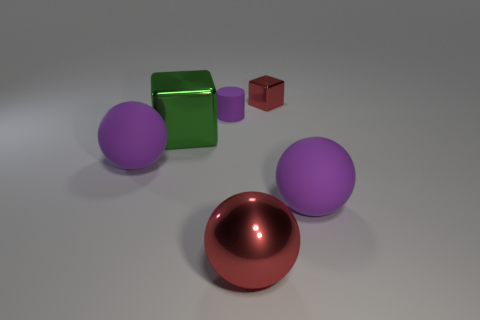Can you describe the texture and material of the objects in the image? Certainly! The objects in the image appear to have a variety of textures and materials. The two purple spheres and the red cube have matte surfaces, which scatter light and give them a non-reflective appearance. The green cube, however, has a glossy finish that reflects light, indicative of a smoother, possibly plastic or polished metal material. The tiny cube in the upper right corner appears metallic with a shiny, reflective surface. 